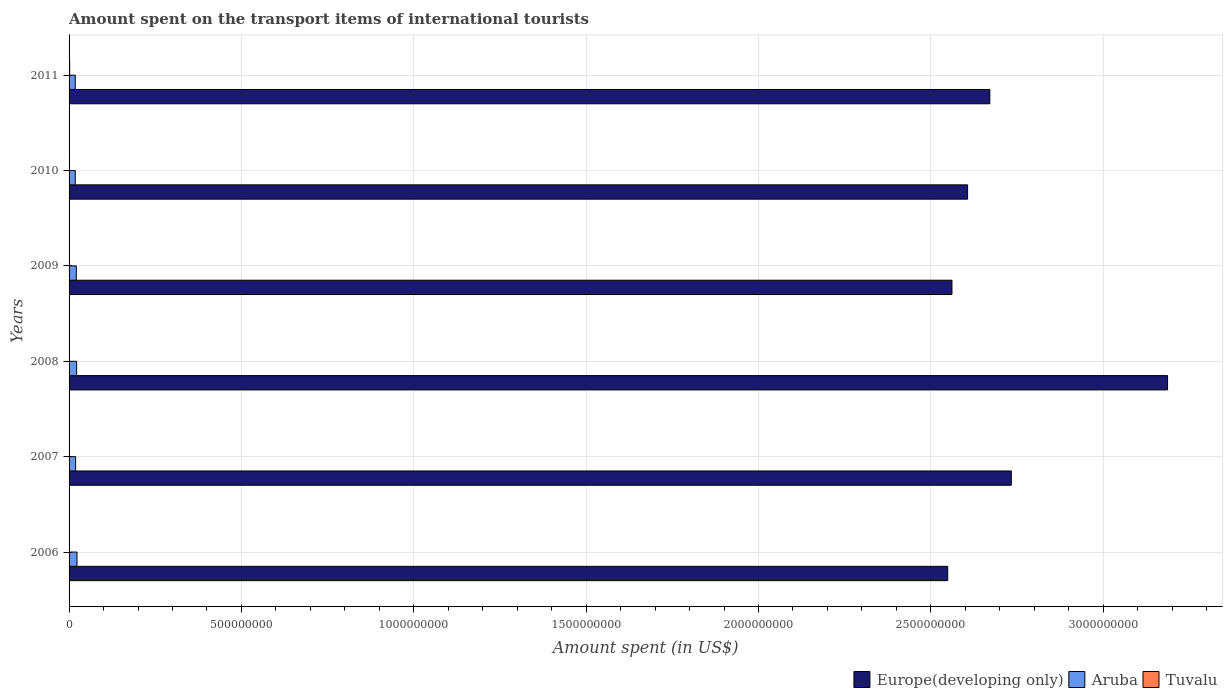How many groups of bars are there?
Provide a short and direct response. 6. Are the number of bars per tick equal to the number of legend labels?
Give a very brief answer. Yes. How many bars are there on the 2nd tick from the top?
Provide a short and direct response. 3. What is the label of the 5th group of bars from the top?
Your answer should be very brief. 2007. What is the amount spent on the transport items of international tourists in Aruba in 2008?
Ensure brevity in your answer.  2.20e+07. Across all years, what is the maximum amount spent on the transport items of international tourists in Aruba?
Your response must be concise. 2.30e+07. Across all years, what is the minimum amount spent on the transport items of international tourists in Europe(developing only)?
Make the answer very short. 2.55e+09. In which year was the amount spent on the transport items of international tourists in Europe(developing only) maximum?
Ensure brevity in your answer.  2008. In which year was the amount spent on the transport items of international tourists in Aruba minimum?
Provide a succinct answer. 2010. What is the total amount spent on the transport items of international tourists in Tuvalu in the graph?
Your answer should be compact. 6.95e+06. What is the difference between the amount spent on the transport items of international tourists in Tuvalu in 2010 and that in 2011?
Offer a very short reply. -5.40e+05. What is the difference between the amount spent on the transport items of international tourists in Aruba in 2009 and the amount spent on the transport items of international tourists in Tuvalu in 2011?
Give a very brief answer. 1.92e+07. What is the average amount spent on the transport items of international tourists in Aruba per year?
Your answer should be compact. 2.02e+07. In the year 2011, what is the difference between the amount spent on the transport items of international tourists in Europe(developing only) and amount spent on the transport items of international tourists in Aruba?
Make the answer very short. 2.65e+09. In how many years, is the amount spent on the transport items of international tourists in Europe(developing only) greater than 3100000000 US$?
Make the answer very short. 1. What is the ratio of the amount spent on the transport items of international tourists in Tuvalu in 2010 to that in 2011?
Offer a terse response. 0.7. Is the amount spent on the transport items of international tourists in Aruba in 2006 less than that in 2008?
Your answer should be compact. No. What is the difference between the highest and the second highest amount spent on the transport items of international tourists in Europe(developing only)?
Offer a terse response. 4.53e+08. What is the difference between the highest and the lowest amount spent on the transport items of international tourists in Aruba?
Provide a succinct answer. 5.00e+06. In how many years, is the amount spent on the transport items of international tourists in Aruba greater than the average amount spent on the transport items of international tourists in Aruba taken over all years?
Provide a succinct answer. 3. What does the 3rd bar from the top in 2009 represents?
Offer a very short reply. Europe(developing only). What does the 3rd bar from the bottom in 2008 represents?
Make the answer very short. Tuvalu. Is it the case that in every year, the sum of the amount spent on the transport items of international tourists in Europe(developing only) and amount spent on the transport items of international tourists in Aruba is greater than the amount spent on the transport items of international tourists in Tuvalu?
Provide a short and direct response. Yes. How many bars are there?
Make the answer very short. 18. Does the graph contain any zero values?
Keep it short and to the point. No. How many legend labels are there?
Your answer should be compact. 3. What is the title of the graph?
Your answer should be very brief. Amount spent on the transport items of international tourists. Does "Least developed countries" appear as one of the legend labels in the graph?
Make the answer very short. No. What is the label or title of the X-axis?
Provide a short and direct response. Amount spent (in US$). What is the Amount spent (in US$) in Europe(developing only) in 2006?
Give a very brief answer. 2.55e+09. What is the Amount spent (in US$) of Aruba in 2006?
Your answer should be compact. 2.30e+07. What is the Amount spent (in US$) of Tuvalu in 2006?
Provide a short and direct response. 4.70e+05. What is the Amount spent (in US$) in Europe(developing only) in 2007?
Make the answer very short. 2.73e+09. What is the Amount spent (in US$) in Aruba in 2007?
Provide a succinct answer. 1.90e+07. What is the Amount spent (in US$) in Europe(developing only) in 2008?
Provide a short and direct response. 3.19e+09. What is the Amount spent (in US$) of Aruba in 2008?
Offer a terse response. 2.20e+07. What is the Amount spent (in US$) in Tuvalu in 2008?
Provide a short and direct response. 1.18e+06. What is the Amount spent (in US$) in Europe(developing only) in 2009?
Provide a succinct answer. 2.56e+09. What is the Amount spent (in US$) in Aruba in 2009?
Provide a short and direct response. 2.10e+07. What is the Amount spent (in US$) in Tuvalu in 2009?
Offer a very short reply. 1.22e+06. What is the Amount spent (in US$) in Europe(developing only) in 2010?
Offer a very short reply. 2.61e+09. What is the Amount spent (in US$) in Aruba in 2010?
Make the answer very short. 1.80e+07. What is the Amount spent (in US$) in Tuvalu in 2010?
Your response must be concise. 1.27e+06. What is the Amount spent (in US$) in Europe(developing only) in 2011?
Your answer should be compact. 2.67e+09. What is the Amount spent (in US$) in Aruba in 2011?
Provide a succinct answer. 1.80e+07. What is the Amount spent (in US$) in Tuvalu in 2011?
Offer a terse response. 1.81e+06. Across all years, what is the maximum Amount spent (in US$) in Europe(developing only)?
Your answer should be compact. 3.19e+09. Across all years, what is the maximum Amount spent (in US$) in Aruba?
Your response must be concise. 2.30e+07. Across all years, what is the maximum Amount spent (in US$) in Tuvalu?
Provide a succinct answer. 1.81e+06. Across all years, what is the minimum Amount spent (in US$) in Europe(developing only)?
Your answer should be very brief. 2.55e+09. Across all years, what is the minimum Amount spent (in US$) in Aruba?
Give a very brief answer. 1.80e+07. Across all years, what is the minimum Amount spent (in US$) of Tuvalu?
Your answer should be compact. 4.70e+05. What is the total Amount spent (in US$) in Europe(developing only) in the graph?
Your response must be concise. 1.63e+1. What is the total Amount spent (in US$) of Aruba in the graph?
Your answer should be very brief. 1.21e+08. What is the total Amount spent (in US$) of Tuvalu in the graph?
Keep it short and to the point. 6.95e+06. What is the difference between the Amount spent (in US$) in Europe(developing only) in 2006 and that in 2007?
Your response must be concise. -1.85e+08. What is the difference between the Amount spent (in US$) in Aruba in 2006 and that in 2007?
Give a very brief answer. 4.00e+06. What is the difference between the Amount spent (in US$) in Tuvalu in 2006 and that in 2007?
Offer a terse response. -5.30e+05. What is the difference between the Amount spent (in US$) of Europe(developing only) in 2006 and that in 2008?
Provide a short and direct response. -6.38e+08. What is the difference between the Amount spent (in US$) of Tuvalu in 2006 and that in 2008?
Give a very brief answer. -7.10e+05. What is the difference between the Amount spent (in US$) of Europe(developing only) in 2006 and that in 2009?
Keep it short and to the point. -1.24e+07. What is the difference between the Amount spent (in US$) in Aruba in 2006 and that in 2009?
Your answer should be very brief. 2.00e+06. What is the difference between the Amount spent (in US$) in Tuvalu in 2006 and that in 2009?
Provide a succinct answer. -7.50e+05. What is the difference between the Amount spent (in US$) of Europe(developing only) in 2006 and that in 2010?
Keep it short and to the point. -5.77e+07. What is the difference between the Amount spent (in US$) in Aruba in 2006 and that in 2010?
Make the answer very short. 5.00e+06. What is the difference between the Amount spent (in US$) in Tuvalu in 2006 and that in 2010?
Give a very brief answer. -8.00e+05. What is the difference between the Amount spent (in US$) in Europe(developing only) in 2006 and that in 2011?
Give a very brief answer. -1.22e+08. What is the difference between the Amount spent (in US$) in Tuvalu in 2006 and that in 2011?
Ensure brevity in your answer.  -1.34e+06. What is the difference between the Amount spent (in US$) of Europe(developing only) in 2007 and that in 2008?
Provide a succinct answer. -4.53e+08. What is the difference between the Amount spent (in US$) of Aruba in 2007 and that in 2008?
Provide a short and direct response. -3.00e+06. What is the difference between the Amount spent (in US$) of Tuvalu in 2007 and that in 2008?
Offer a terse response. -1.80e+05. What is the difference between the Amount spent (in US$) in Europe(developing only) in 2007 and that in 2009?
Provide a succinct answer. 1.72e+08. What is the difference between the Amount spent (in US$) in Tuvalu in 2007 and that in 2009?
Give a very brief answer. -2.20e+05. What is the difference between the Amount spent (in US$) in Europe(developing only) in 2007 and that in 2010?
Keep it short and to the point. 1.27e+08. What is the difference between the Amount spent (in US$) in Europe(developing only) in 2007 and that in 2011?
Provide a succinct answer. 6.23e+07. What is the difference between the Amount spent (in US$) of Tuvalu in 2007 and that in 2011?
Offer a very short reply. -8.10e+05. What is the difference between the Amount spent (in US$) in Europe(developing only) in 2008 and that in 2009?
Make the answer very short. 6.25e+08. What is the difference between the Amount spent (in US$) in Tuvalu in 2008 and that in 2009?
Give a very brief answer. -4.00e+04. What is the difference between the Amount spent (in US$) of Europe(developing only) in 2008 and that in 2010?
Ensure brevity in your answer.  5.80e+08. What is the difference between the Amount spent (in US$) in Aruba in 2008 and that in 2010?
Provide a short and direct response. 4.00e+06. What is the difference between the Amount spent (in US$) of Europe(developing only) in 2008 and that in 2011?
Keep it short and to the point. 5.16e+08. What is the difference between the Amount spent (in US$) of Aruba in 2008 and that in 2011?
Offer a terse response. 4.00e+06. What is the difference between the Amount spent (in US$) of Tuvalu in 2008 and that in 2011?
Provide a short and direct response. -6.30e+05. What is the difference between the Amount spent (in US$) of Europe(developing only) in 2009 and that in 2010?
Keep it short and to the point. -4.53e+07. What is the difference between the Amount spent (in US$) of Aruba in 2009 and that in 2010?
Provide a succinct answer. 3.00e+06. What is the difference between the Amount spent (in US$) in Europe(developing only) in 2009 and that in 2011?
Offer a terse response. -1.10e+08. What is the difference between the Amount spent (in US$) of Tuvalu in 2009 and that in 2011?
Ensure brevity in your answer.  -5.90e+05. What is the difference between the Amount spent (in US$) of Europe(developing only) in 2010 and that in 2011?
Ensure brevity in your answer.  -6.46e+07. What is the difference between the Amount spent (in US$) of Tuvalu in 2010 and that in 2011?
Offer a very short reply. -5.40e+05. What is the difference between the Amount spent (in US$) in Europe(developing only) in 2006 and the Amount spent (in US$) in Aruba in 2007?
Provide a short and direct response. 2.53e+09. What is the difference between the Amount spent (in US$) in Europe(developing only) in 2006 and the Amount spent (in US$) in Tuvalu in 2007?
Provide a short and direct response. 2.55e+09. What is the difference between the Amount spent (in US$) in Aruba in 2006 and the Amount spent (in US$) in Tuvalu in 2007?
Your answer should be very brief. 2.20e+07. What is the difference between the Amount spent (in US$) of Europe(developing only) in 2006 and the Amount spent (in US$) of Aruba in 2008?
Provide a short and direct response. 2.53e+09. What is the difference between the Amount spent (in US$) in Europe(developing only) in 2006 and the Amount spent (in US$) in Tuvalu in 2008?
Make the answer very short. 2.55e+09. What is the difference between the Amount spent (in US$) in Aruba in 2006 and the Amount spent (in US$) in Tuvalu in 2008?
Your response must be concise. 2.18e+07. What is the difference between the Amount spent (in US$) of Europe(developing only) in 2006 and the Amount spent (in US$) of Aruba in 2009?
Your answer should be compact. 2.53e+09. What is the difference between the Amount spent (in US$) of Europe(developing only) in 2006 and the Amount spent (in US$) of Tuvalu in 2009?
Your answer should be compact. 2.55e+09. What is the difference between the Amount spent (in US$) of Aruba in 2006 and the Amount spent (in US$) of Tuvalu in 2009?
Offer a terse response. 2.18e+07. What is the difference between the Amount spent (in US$) of Europe(developing only) in 2006 and the Amount spent (in US$) of Aruba in 2010?
Your response must be concise. 2.53e+09. What is the difference between the Amount spent (in US$) of Europe(developing only) in 2006 and the Amount spent (in US$) of Tuvalu in 2010?
Your answer should be very brief. 2.55e+09. What is the difference between the Amount spent (in US$) of Aruba in 2006 and the Amount spent (in US$) of Tuvalu in 2010?
Offer a very short reply. 2.17e+07. What is the difference between the Amount spent (in US$) in Europe(developing only) in 2006 and the Amount spent (in US$) in Aruba in 2011?
Offer a terse response. 2.53e+09. What is the difference between the Amount spent (in US$) of Europe(developing only) in 2006 and the Amount spent (in US$) of Tuvalu in 2011?
Your answer should be compact. 2.55e+09. What is the difference between the Amount spent (in US$) in Aruba in 2006 and the Amount spent (in US$) in Tuvalu in 2011?
Offer a terse response. 2.12e+07. What is the difference between the Amount spent (in US$) in Europe(developing only) in 2007 and the Amount spent (in US$) in Aruba in 2008?
Provide a short and direct response. 2.71e+09. What is the difference between the Amount spent (in US$) in Europe(developing only) in 2007 and the Amount spent (in US$) in Tuvalu in 2008?
Provide a succinct answer. 2.73e+09. What is the difference between the Amount spent (in US$) of Aruba in 2007 and the Amount spent (in US$) of Tuvalu in 2008?
Ensure brevity in your answer.  1.78e+07. What is the difference between the Amount spent (in US$) in Europe(developing only) in 2007 and the Amount spent (in US$) in Aruba in 2009?
Ensure brevity in your answer.  2.71e+09. What is the difference between the Amount spent (in US$) of Europe(developing only) in 2007 and the Amount spent (in US$) of Tuvalu in 2009?
Your response must be concise. 2.73e+09. What is the difference between the Amount spent (in US$) in Aruba in 2007 and the Amount spent (in US$) in Tuvalu in 2009?
Your answer should be compact. 1.78e+07. What is the difference between the Amount spent (in US$) of Europe(developing only) in 2007 and the Amount spent (in US$) of Aruba in 2010?
Your answer should be very brief. 2.72e+09. What is the difference between the Amount spent (in US$) of Europe(developing only) in 2007 and the Amount spent (in US$) of Tuvalu in 2010?
Give a very brief answer. 2.73e+09. What is the difference between the Amount spent (in US$) in Aruba in 2007 and the Amount spent (in US$) in Tuvalu in 2010?
Provide a succinct answer. 1.77e+07. What is the difference between the Amount spent (in US$) in Europe(developing only) in 2007 and the Amount spent (in US$) in Aruba in 2011?
Offer a terse response. 2.72e+09. What is the difference between the Amount spent (in US$) in Europe(developing only) in 2007 and the Amount spent (in US$) in Tuvalu in 2011?
Your answer should be compact. 2.73e+09. What is the difference between the Amount spent (in US$) of Aruba in 2007 and the Amount spent (in US$) of Tuvalu in 2011?
Your answer should be very brief. 1.72e+07. What is the difference between the Amount spent (in US$) of Europe(developing only) in 2008 and the Amount spent (in US$) of Aruba in 2009?
Give a very brief answer. 3.17e+09. What is the difference between the Amount spent (in US$) of Europe(developing only) in 2008 and the Amount spent (in US$) of Tuvalu in 2009?
Keep it short and to the point. 3.19e+09. What is the difference between the Amount spent (in US$) of Aruba in 2008 and the Amount spent (in US$) of Tuvalu in 2009?
Provide a succinct answer. 2.08e+07. What is the difference between the Amount spent (in US$) of Europe(developing only) in 2008 and the Amount spent (in US$) of Aruba in 2010?
Provide a short and direct response. 3.17e+09. What is the difference between the Amount spent (in US$) of Europe(developing only) in 2008 and the Amount spent (in US$) of Tuvalu in 2010?
Provide a short and direct response. 3.19e+09. What is the difference between the Amount spent (in US$) in Aruba in 2008 and the Amount spent (in US$) in Tuvalu in 2010?
Offer a very short reply. 2.07e+07. What is the difference between the Amount spent (in US$) of Europe(developing only) in 2008 and the Amount spent (in US$) of Aruba in 2011?
Ensure brevity in your answer.  3.17e+09. What is the difference between the Amount spent (in US$) in Europe(developing only) in 2008 and the Amount spent (in US$) in Tuvalu in 2011?
Your answer should be very brief. 3.18e+09. What is the difference between the Amount spent (in US$) in Aruba in 2008 and the Amount spent (in US$) in Tuvalu in 2011?
Offer a terse response. 2.02e+07. What is the difference between the Amount spent (in US$) of Europe(developing only) in 2009 and the Amount spent (in US$) of Aruba in 2010?
Make the answer very short. 2.54e+09. What is the difference between the Amount spent (in US$) in Europe(developing only) in 2009 and the Amount spent (in US$) in Tuvalu in 2010?
Ensure brevity in your answer.  2.56e+09. What is the difference between the Amount spent (in US$) of Aruba in 2009 and the Amount spent (in US$) of Tuvalu in 2010?
Provide a succinct answer. 1.97e+07. What is the difference between the Amount spent (in US$) in Europe(developing only) in 2009 and the Amount spent (in US$) in Aruba in 2011?
Give a very brief answer. 2.54e+09. What is the difference between the Amount spent (in US$) in Europe(developing only) in 2009 and the Amount spent (in US$) in Tuvalu in 2011?
Your response must be concise. 2.56e+09. What is the difference between the Amount spent (in US$) in Aruba in 2009 and the Amount spent (in US$) in Tuvalu in 2011?
Your answer should be very brief. 1.92e+07. What is the difference between the Amount spent (in US$) in Europe(developing only) in 2010 and the Amount spent (in US$) in Aruba in 2011?
Give a very brief answer. 2.59e+09. What is the difference between the Amount spent (in US$) in Europe(developing only) in 2010 and the Amount spent (in US$) in Tuvalu in 2011?
Your answer should be very brief. 2.60e+09. What is the difference between the Amount spent (in US$) in Aruba in 2010 and the Amount spent (in US$) in Tuvalu in 2011?
Keep it short and to the point. 1.62e+07. What is the average Amount spent (in US$) in Europe(developing only) per year?
Your answer should be compact. 2.72e+09. What is the average Amount spent (in US$) in Aruba per year?
Offer a very short reply. 2.02e+07. What is the average Amount spent (in US$) of Tuvalu per year?
Make the answer very short. 1.16e+06. In the year 2006, what is the difference between the Amount spent (in US$) in Europe(developing only) and Amount spent (in US$) in Aruba?
Offer a terse response. 2.53e+09. In the year 2006, what is the difference between the Amount spent (in US$) of Europe(developing only) and Amount spent (in US$) of Tuvalu?
Provide a succinct answer. 2.55e+09. In the year 2006, what is the difference between the Amount spent (in US$) in Aruba and Amount spent (in US$) in Tuvalu?
Offer a terse response. 2.25e+07. In the year 2007, what is the difference between the Amount spent (in US$) of Europe(developing only) and Amount spent (in US$) of Aruba?
Provide a short and direct response. 2.71e+09. In the year 2007, what is the difference between the Amount spent (in US$) in Europe(developing only) and Amount spent (in US$) in Tuvalu?
Your response must be concise. 2.73e+09. In the year 2007, what is the difference between the Amount spent (in US$) in Aruba and Amount spent (in US$) in Tuvalu?
Ensure brevity in your answer.  1.80e+07. In the year 2008, what is the difference between the Amount spent (in US$) in Europe(developing only) and Amount spent (in US$) in Aruba?
Provide a succinct answer. 3.16e+09. In the year 2008, what is the difference between the Amount spent (in US$) of Europe(developing only) and Amount spent (in US$) of Tuvalu?
Offer a very short reply. 3.19e+09. In the year 2008, what is the difference between the Amount spent (in US$) of Aruba and Amount spent (in US$) of Tuvalu?
Keep it short and to the point. 2.08e+07. In the year 2009, what is the difference between the Amount spent (in US$) of Europe(developing only) and Amount spent (in US$) of Aruba?
Ensure brevity in your answer.  2.54e+09. In the year 2009, what is the difference between the Amount spent (in US$) of Europe(developing only) and Amount spent (in US$) of Tuvalu?
Offer a very short reply. 2.56e+09. In the year 2009, what is the difference between the Amount spent (in US$) of Aruba and Amount spent (in US$) of Tuvalu?
Provide a succinct answer. 1.98e+07. In the year 2010, what is the difference between the Amount spent (in US$) of Europe(developing only) and Amount spent (in US$) of Aruba?
Offer a terse response. 2.59e+09. In the year 2010, what is the difference between the Amount spent (in US$) of Europe(developing only) and Amount spent (in US$) of Tuvalu?
Make the answer very short. 2.61e+09. In the year 2010, what is the difference between the Amount spent (in US$) of Aruba and Amount spent (in US$) of Tuvalu?
Make the answer very short. 1.67e+07. In the year 2011, what is the difference between the Amount spent (in US$) in Europe(developing only) and Amount spent (in US$) in Aruba?
Your response must be concise. 2.65e+09. In the year 2011, what is the difference between the Amount spent (in US$) in Europe(developing only) and Amount spent (in US$) in Tuvalu?
Make the answer very short. 2.67e+09. In the year 2011, what is the difference between the Amount spent (in US$) in Aruba and Amount spent (in US$) in Tuvalu?
Your answer should be very brief. 1.62e+07. What is the ratio of the Amount spent (in US$) in Europe(developing only) in 2006 to that in 2007?
Your response must be concise. 0.93. What is the ratio of the Amount spent (in US$) of Aruba in 2006 to that in 2007?
Give a very brief answer. 1.21. What is the ratio of the Amount spent (in US$) in Tuvalu in 2006 to that in 2007?
Provide a short and direct response. 0.47. What is the ratio of the Amount spent (in US$) in Europe(developing only) in 2006 to that in 2008?
Offer a very short reply. 0.8. What is the ratio of the Amount spent (in US$) of Aruba in 2006 to that in 2008?
Keep it short and to the point. 1.05. What is the ratio of the Amount spent (in US$) of Tuvalu in 2006 to that in 2008?
Offer a terse response. 0.4. What is the ratio of the Amount spent (in US$) of Aruba in 2006 to that in 2009?
Provide a short and direct response. 1.1. What is the ratio of the Amount spent (in US$) of Tuvalu in 2006 to that in 2009?
Give a very brief answer. 0.39. What is the ratio of the Amount spent (in US$) of Europe(developing only) in 2006 to that in 2010?
Provide a short and direct response. 0.98. What is the ratio of the Amount spent (in US$) of Aruba in 2006 to that in 2010?
Keep it short and to the point. 1.28. What is the ratio of the Amount spent (in US$) of Tuvalu in 2006 to that in 2010?
Your answer should be compact. 0.37. What is the ratio of the Amount spent (in US$) in Europe(developing only) in 2006 to that in 2011?
Your response must be concise. 0.95. What is the ratio of the Amount spent (in US$) in Aruba in 2006 to that in 2011?
Make the answer very short. 1.28. What is the ratio of the Amount spent (in US$) of Tuvalu in 2006 to that in 2011?
Your response must be concise. 0.26. What is the ratio of the Amount spent (in US$) of Europe(developing only) in 2007 to that in 2008?
Keep it short and to the point. 0.86. What is the ratio of the Amount spent (in US$) of Aruba in 2007 to that in 2008?
Offer a terse response. 0.86. What is the ratio of the Amount spent (in US$) in Tuvalu in 2007 to that in 2008?
Keep it short and to the point. 0.85. What is the ratio of the Amount spent (in US$) in Europe(developing only) in 2007 to that in 2009?
Your response must be concise. 1.07. What is the ratio of the Amount spent (in US$) of Aruba in 2007 to that in 2009?
Offer a very short reply. 0.9. What is the ratio of the Amount spent (in US$) in Tuvalu in 2007 to that in 2009?
Provide a short and direct response. 0.82. What is the ratio of the Amount spent (in US$) in Europe(developing only) in 2007 to that in 2010?
Your answer should be very brief. 1.05. What is the ratio of the Amount spent (in US$) in Aruba in 2007 to that in 2010?
Ensure brevity in your answer.  1.06. What is the ratio of the Amount spent (in US$) in Tuvalu in 2007 to that in 2010?
Your answer should be very brief. 0.79. What is the ratio of the Amount spent (in US$) in Europe(developing only) in 2007 to that in 2011?
Your answer should be compact. 1.02. What is the ratio of the Amount spent (in US$) in Aruba in 2007 to that in 2011?
Make the answer very short. 1.06. What is the ratio of the Amount spent (in US$) of Tuvalu in 2007 to that in 2011?
Offer a very short reply. 0.55. What is the ratio of the Amount spent (in US$) in Europe(developing only) in 2008 to that in 2009?
Ensure brevity in your answer.  1.24. What is the ratio of the Amount spent (in US$) of Aruba in 2008 to that in 2009?
Ensure brevity in your answer.  1.05. What is the ratio of the Amount spent (in US$) in Tuvalu in 2008 to that in 2009?
Keep it short and to the point. 0.97. What is the ratio of the Amount spent (in US$) in Europe(developing only) in 2008 to that in 2010?
Offer a terse response. 1.22. What is the ratio of the Amount spent (in US$) of Aruba in 2008 to that in 2010?
Provide a succinct answer. 1.22. What is the ratio of the Amount spent (in US$) in Tuvalu in 2008 to that in 2010?
Your answer should be very brief. 0.93. What is the ratio of the Amount spent (in US$) of Europe(developing only) in 2008 to that in 2011?
Ensure brevity in your answer.  1.19. What is the ratio of the Amount spent (in US$) in Aruba in 2008 to that in 2011?
Offer a terse response. 1.22. What is the ratio of the Amount spent (in US$) in Tuvalu in 2008 to that in 2011?
Provide a short and direct response. 0.65. What is the ratio of the Amount spent (in US$) in Europe(developing only) in 2009 to that in 2010?
Your response must be concise. 0.98. What is the ratio of the Amount spent (in US$) of Tuvalu in 2009 to that in 2010?
Offer a terse response. 0.96. What is the ratio of the Amount spent (in US$) of Europe(developing only) in 2009 to that in 2011?
Provide a succinct answer. 0.96. What is the ratio of the Amount spent (in US$) in Tuvalu in 2009 to that in 2011?
Offer a terse response. 0.67. What is the ratio of the Amount spent (in US$) in Europe(developing only) in 2010 to that in 2011?
Offer a very short reply. 0.98. What is the ratio of the Amount spent (in US$) in Aruba in 2010 to that in 2011?
Give a very brief answer. 1. What is the ratio of the Amount spent (in US$) in Tuvalu in 2010 to that in 2011?
Keep it short and to the point. 0.7. What is the difference between the highest and the second highest Amount spent (in US$) in Europe(developing only)?
Your answer should be very brief. 4.53e+08. What is the difference between the highest and the second highest Amount spent (in US$) of Aruba?
Offer a terse response. 1.00e+06. What is the difference between the highest and the second highest Amount spent (in US$) in Tuvalu?
Provide a succinct answer. 5.40e+05. What is the difference between the highest and the lowest Amount spent (in US$) of Europe(developing only)?
Offer a very short reply. 6.38e+08. What is the difference between the highest and the lowest Amount spent (in US$) in Tuvalu?
Keep it short and to the point. 1.34e+06. 